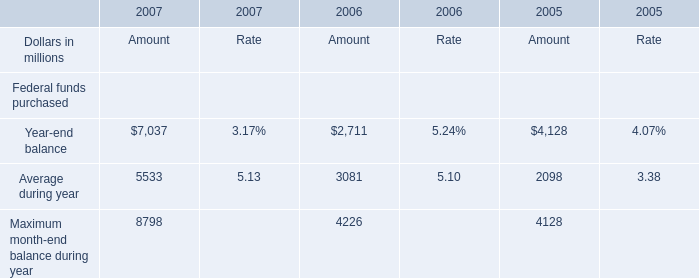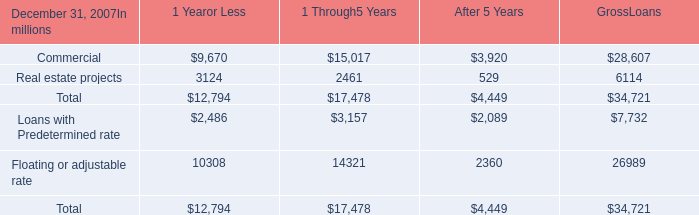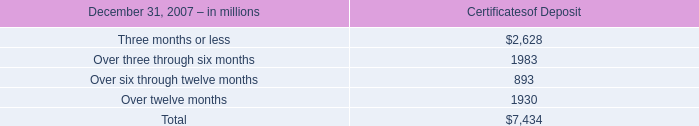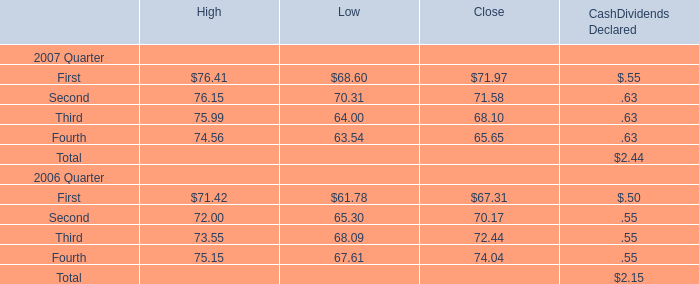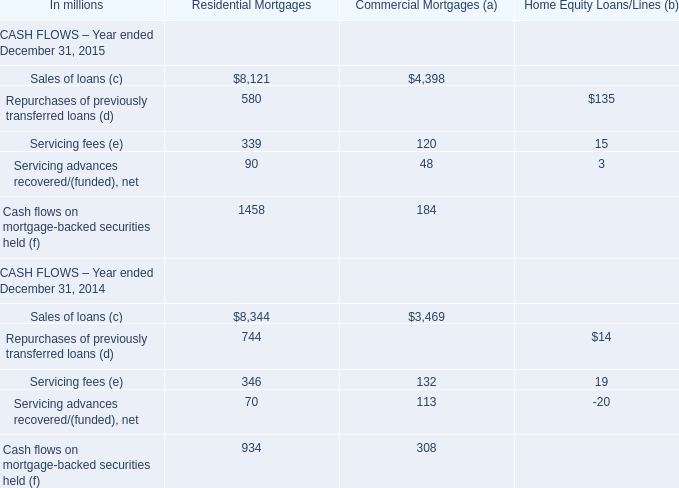In the year where the Amount for Average during year is the highest, what's the increasing rate of the Amount for Year-end balance? 
Computations: ((7037 - 2711) / 2711)
Answer: 1.59572. 